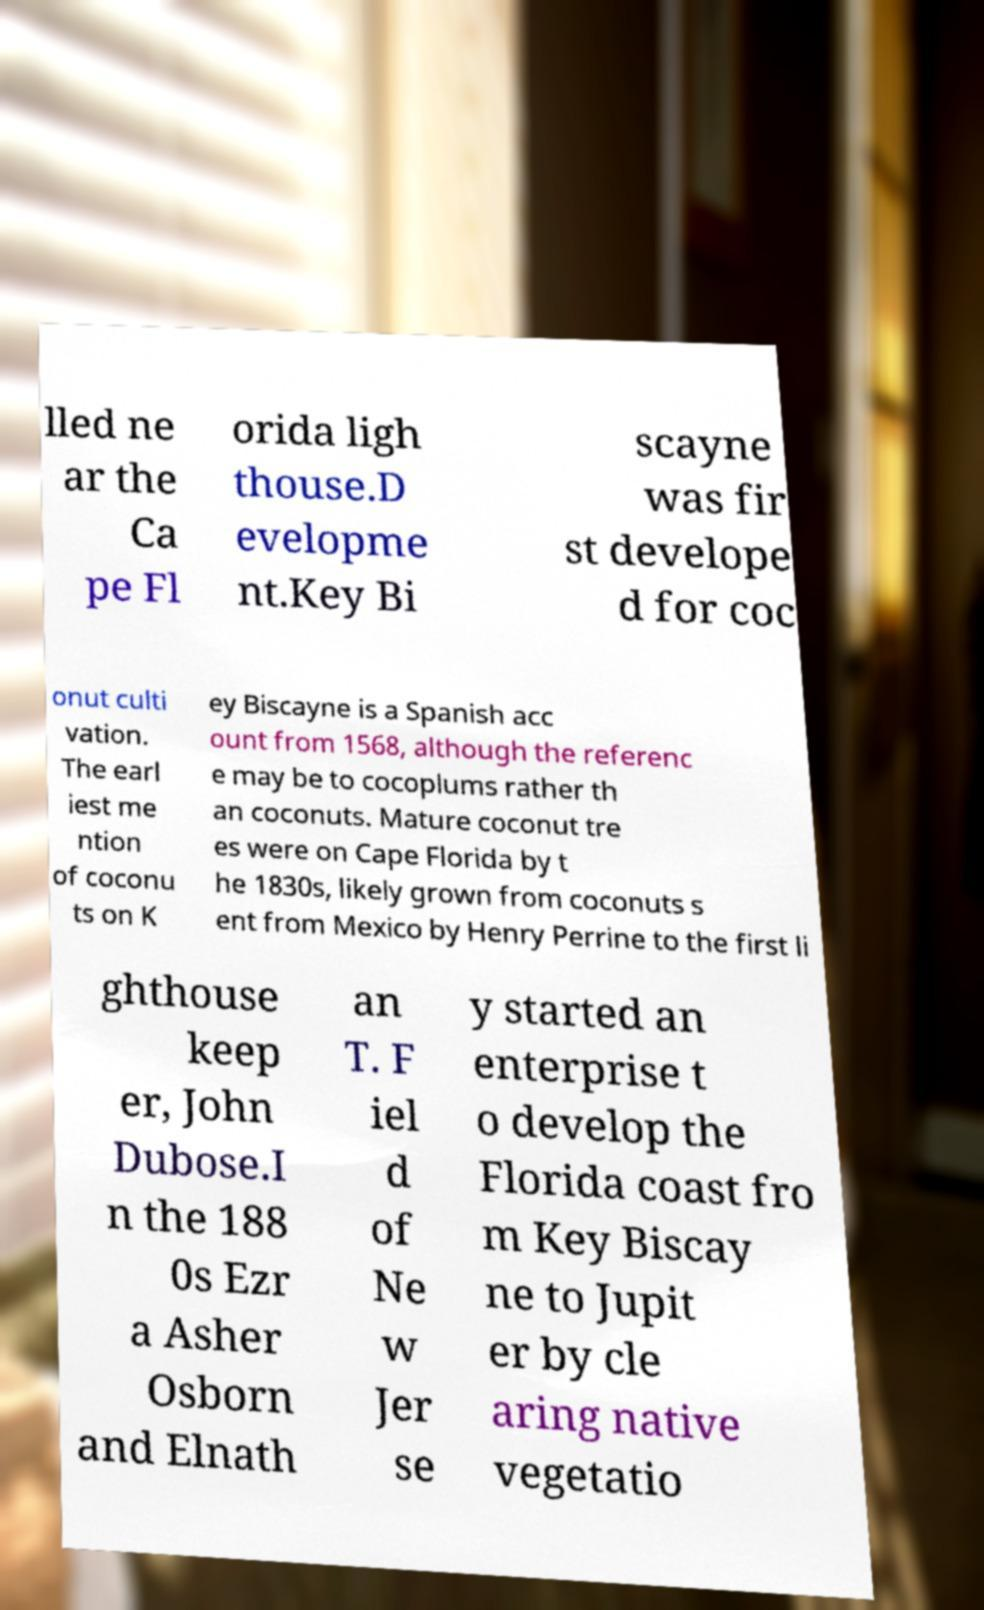For documentation purposes, I need the text within this image transcribed. Could you provide that? lled ne ar the Ca pe Fl orida ligh thouse.D evelopme nt.Key Bi scayne was fir st develope d for coc onut culti vation. The earl iest me ntion of coconu ts on K ey Biscayne is a Spanish acc ount from 1568, although the referenc e may be to cocoplums rather th an coconuts. Mature coconut tre es were on Cape Florida by t he 1830s, likely grown from coconuts s ent from Mexico by Henry Perrine to the first li ghthouse keep er, John Dubose.I n the 188 0s Ezr a Asher Osborn and Elnath an T. F iel d of Ne w Jer se y started an enterprise t o develop the Florida coast fro m Key Biscay ne to Jupit er by cle aring native vegetatio 